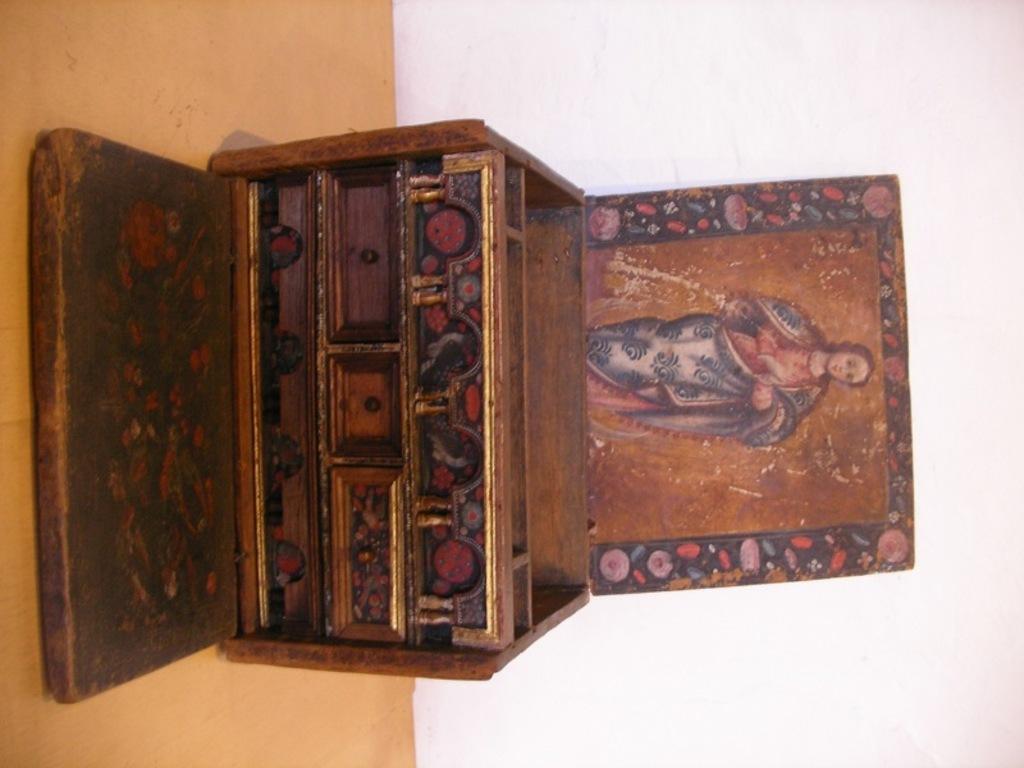Can you describe this image briefly? In the center of the image, we can see a box with lid opened and we can see a wooden plank. In the background, there is a wall and at the bottom, there is floor. 